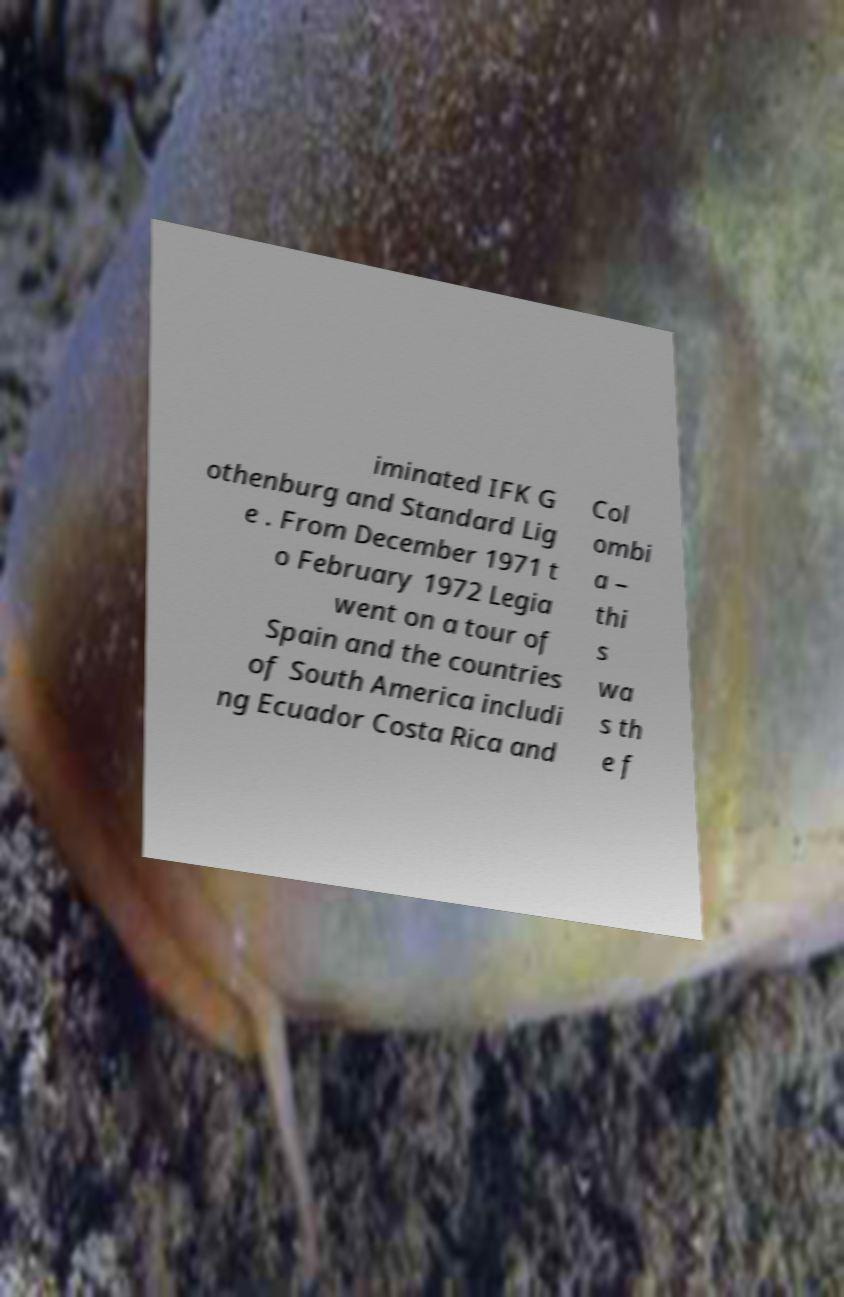What messages or text are displayed in this image? I need them in a readable, typed format. iminated IFK G othenburg and Standard Lig e . From December 1971 t o February 1972 Legia went on a tour of Spain and the countries of South America includi ng Ecuador Costa Rica and Col ombi a – thi s wa s th e f 